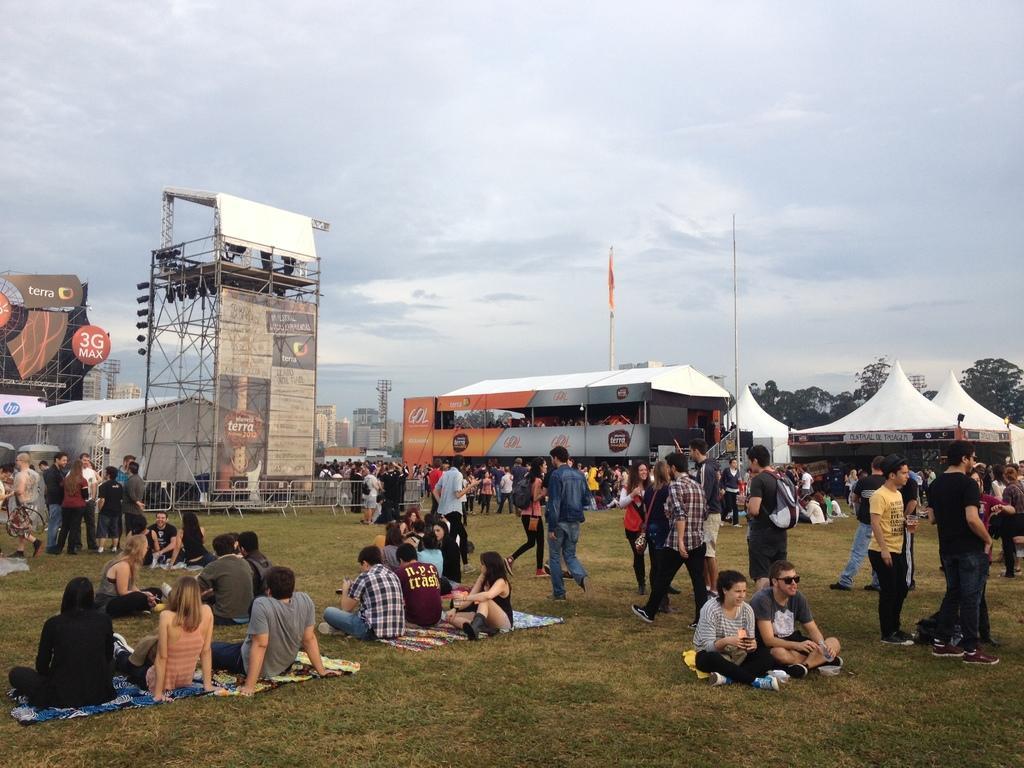In one or two sentences, can you explain what this image depicts? There are persons in different color dresses, some of them are sitting on the ground, on which there is grass. In the background, there are hoardings, white color tents, there are trees, buildings and there are clouds in the sky. 